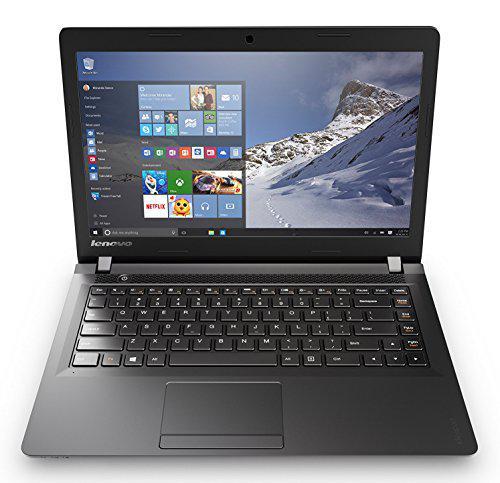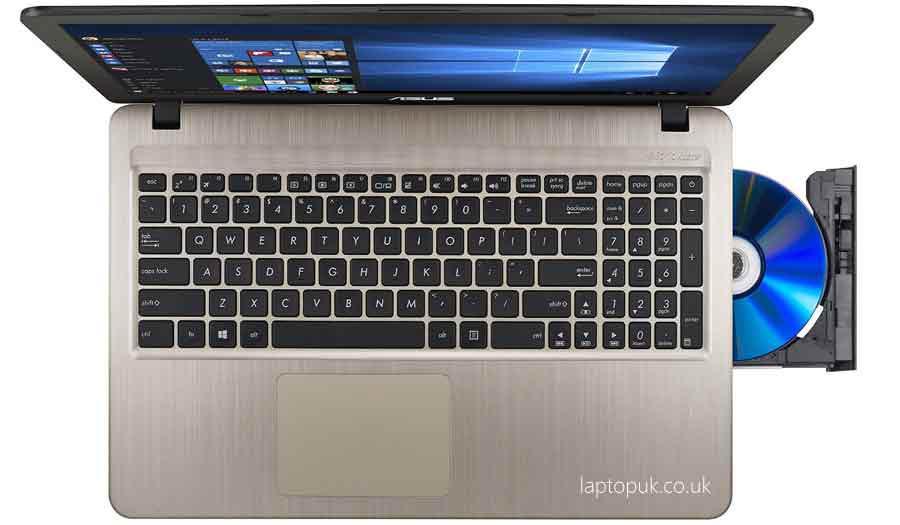The first image is the image on the left, the second image is the image on the right. For the images displayed, is the sentence "The open laptop on the right is shown in an aerial view with a CD sticking out of the side, while the laptop on the left does not have a CD sticking out." factually correct? Answer yes or no. Yes. 